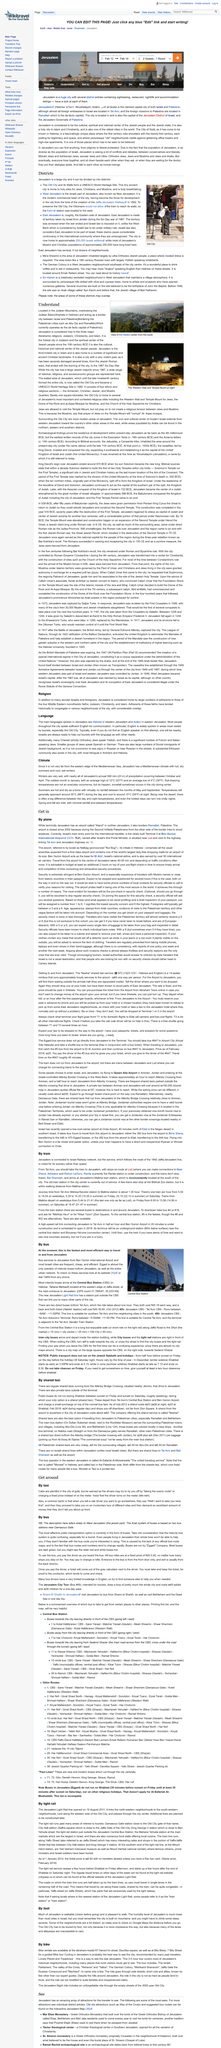Mention a couple of crucial points in this snapshot. The Jaffa-Jerusalem line was built in the year 1892. Cabs are plentiful in the city of gold, making them easily accessible to its residents and visitors alike. Jerusalem has a Mediterranean climate with hot, dry summers and cool, wet winters. There are approximately 200,000 Israeli settlers currently residing in East Jerusalem. The image depicts the Old City district of Jerusalem. 